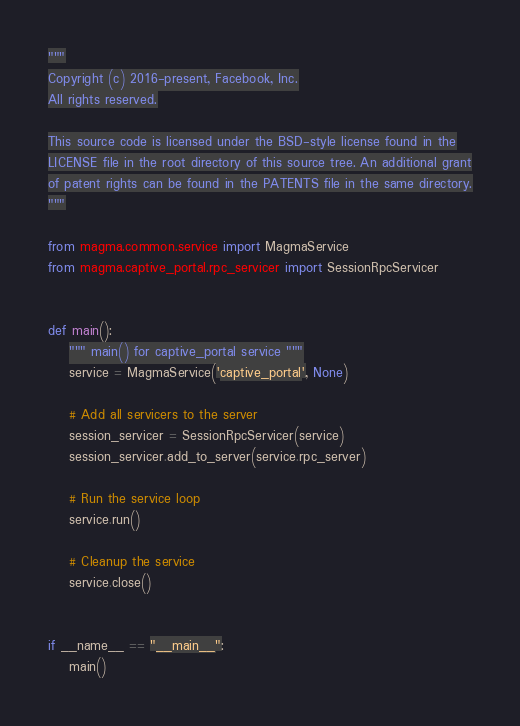Convert code to text. <code><loc_0><loc_0><loc_500><loc_500><_Python_>"""
Copyright (c) 2016-present, Facebook, Inc.
All rights reserved.

This source code is licensed under the BSD-style license found in the
LICENSE file in the root directory of this source tree. An additional grant
of patent rights can be found in the PATENTS file in the same directory.
"""

from magma.common.service import MagmaService
from magma.captive_portal.rpc_servicer import SessionRpcServicer


def main():
    """ main() for captive_portal service """
    service = MagmaService('captive_portal', None)

    # Add all servicers to the server
    session_servicer = SessionRpcServicer(service)
    session_servicer.add_to_server(service.rpc_server)

    # Run the service loop
    service.run()

    # Cleanup the service
    service.close()


if __name__ == "__main__":
    main()
</code> 